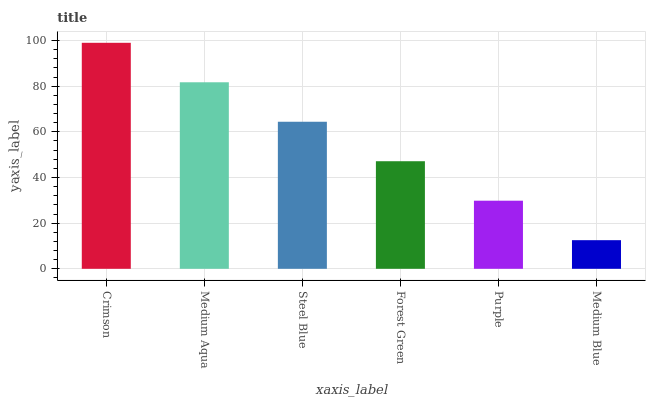Is Medium Blue the minimum?
Answer yes or no. Yes. Is Crimson the maximum?
Answer yes or no. Yes. Is Medium Aqua the minimum?
Answer yes or no. No. Is Medium Aqua the maximum?
Answer yes or no. No. Is Crimson greater than Medium Aqua?
Answer yes or no. Yes. Is Medium Aqua less than Crimson?
Answer yes or no. Yes. Is Medium Aqua greater than Crimson?
Answer yes or no. No. Is Crimson less than Medium Aqua?
Answer yes or no. No. Is Steel Blue the high median?
Answer yes or no. Yes. Is Forest Green the low median?
Answer yes or no. Yes. Is Forest Green the high median?
Answer yes or no. No. Is Medium Aqua the low median?
Answer yes or no. No. 